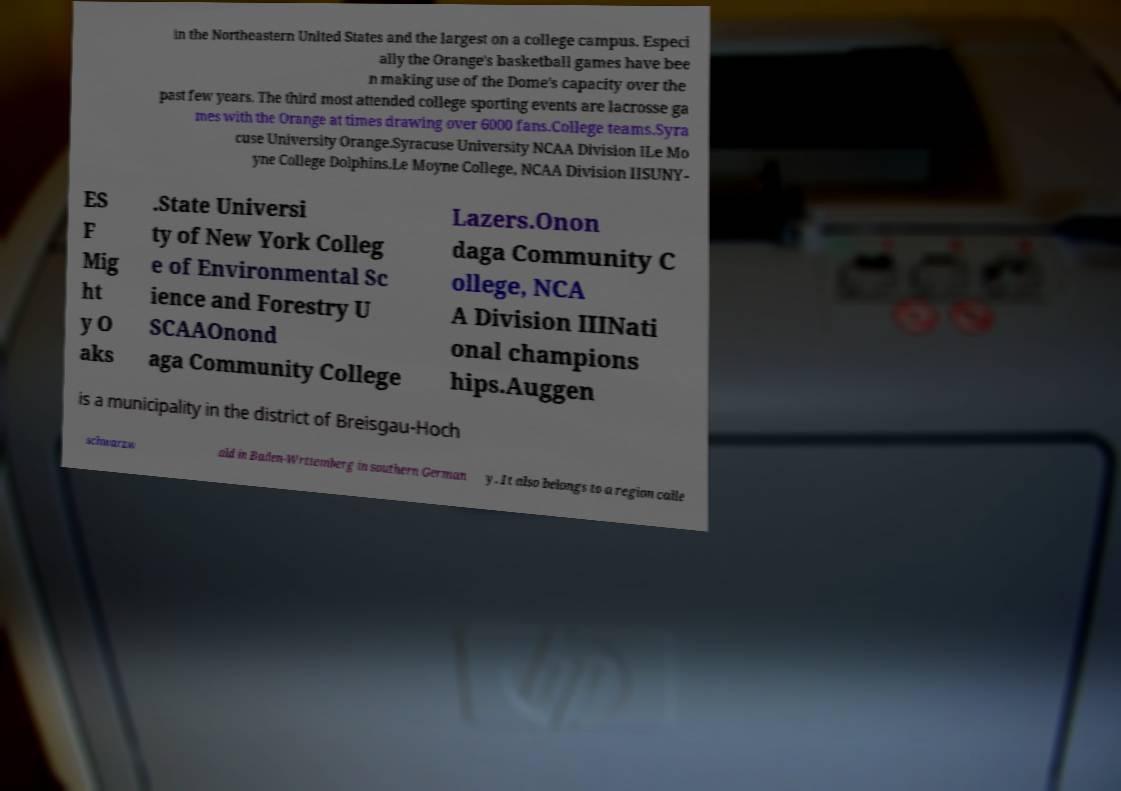Could you assist in decoding the text presented in this image and type it out clearly? in the Northeastern United States and the largest on a college campus. Especi ally the Orange's basketball games have bee n making use of the Dome's capacity over the past few years. The third most attended college sporting events are lacrosse ga mes with the Orange at times drawing over 6000 fans.College teams.Syra cuse University Orange.Syracuse University NCAA Division ILe Mo yne College Dolphins.Le Moyne College, NCAA Division IISUNY- ES F Mig ht y O aks .State Universi ty of New York Colleg e of Environmental Sc ience and Forestry U SCAAOnond aga Community College Lazers.Onon daga Community C ollege, NCA A Division IIINati onal champions hips.Auggen is a municipality in the district of Breisgau-Hoch schwarzw ald in Baden-Wrttemberg in southern German y. It also belongs to a region calle 